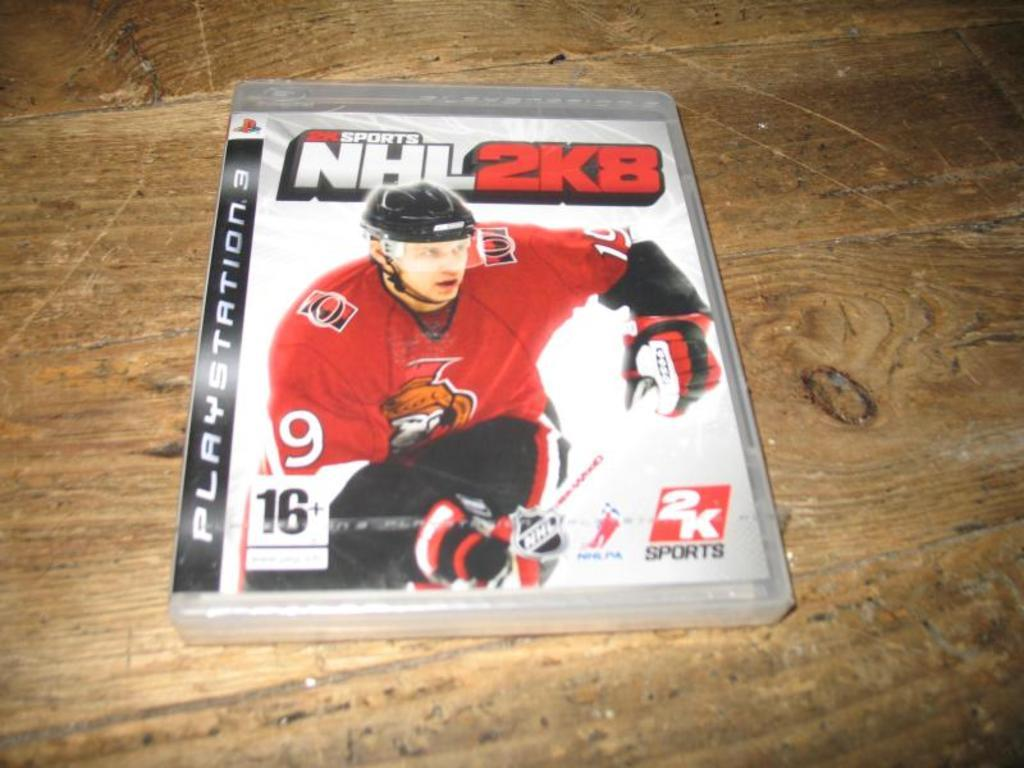What object is featured in the image that contains a picture? The image contains a DVD case. What is depicted on the DVD case? There is a picture of a man on the DVD case. What else can be seen on the DVD case besides the picture? There are letters on the DVD case. What material does the DVD case appear to be made of? The DVD case appears to be made of wood. Can you tell me how many beggars are visible in the image? There are no beggars present in the image; it features a DVD case with a picture of a man. What type of deer can be seen walking through the window in the image? There is no deer or window present in the image; it features a DVD case made of wood. 